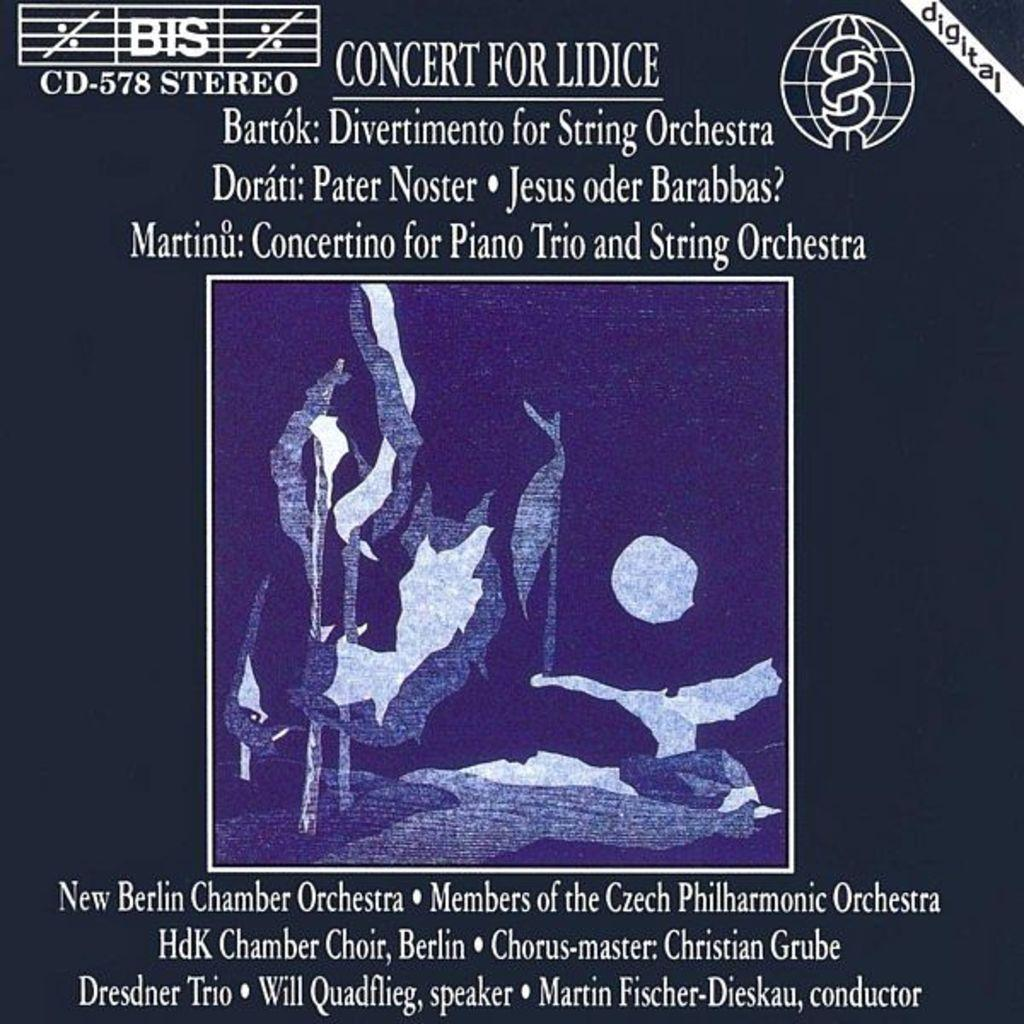<image>
Provide a brief description of the given image. A blue advertisement for the Concert for Lidice. 